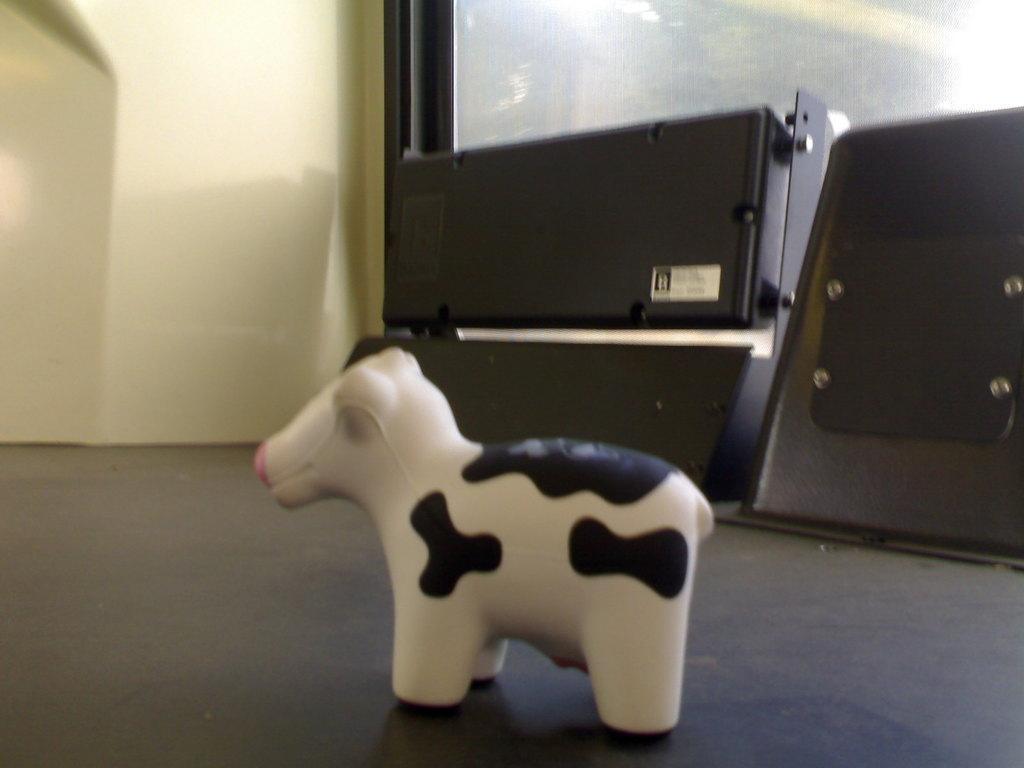Please provide a concise description of this image. In this picture we can see a toy on the floor and in the background we can see a wall and some objects. 